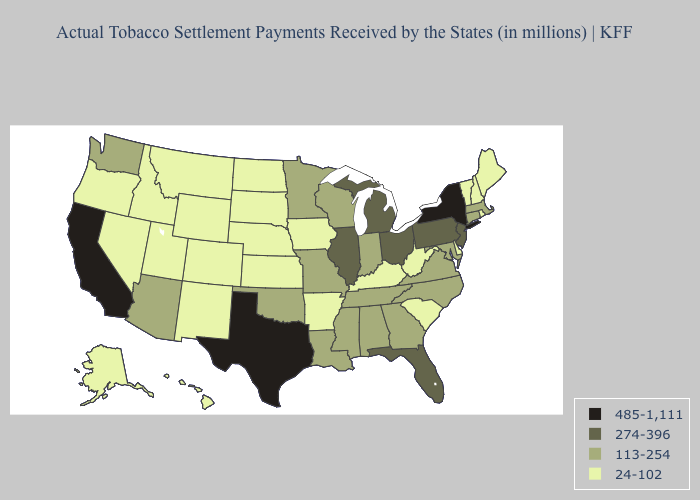What is the lowest value in states that border Indiana?
Short answer required. 24-102. Does Texas have the highest value in the USA?
Quick response, please. Yes. Does South Carolina have the lowest value in the South?
Concise answer only. Yes. Among the states that border Maine , which have the lowest value?
Short answer required. New Hampshire. What is the lowest value in states that border Arizona?
Be succinct. 24-102. What is the lowest value in the MidWest?
Answer briefly. 24-102. Name the states that have a value in the range 274-396?
Be succinct. Florida, Illinois, Michigan, New Jersey, Ohio, Pennsylvania. Does the map have missing data?
Give a very brief answer. No. Among the states that border California , which have the lowest value?
Quick response, please. Nevada, Oregon. Does the map have missing data?
Short answer required. No. Does the map have missing data?
Answer briefly. No. Name the states that have a value in the range 24-102?
Write a very short answer. Alaska, Arkansas, Colorado, Delaware, Hawaii, Idaho, Iowa, Kansas, Kentucky, Maine, Montana, Nebraska, Nevada, New Hampshire, New Mexico, North Dakota, Oregon, Rhode Island, South Carolina, South Dakota, Utah, Vermont, West Virginia, Wyoming. Among the states that border Connecticut , does Massachusetts have the highest value?
Answer briefly. No. Does the first symbol in the legend represent the smallest category?
Short answer required. No. What is the lowest value in the South?
Be succinct. 24-102. 